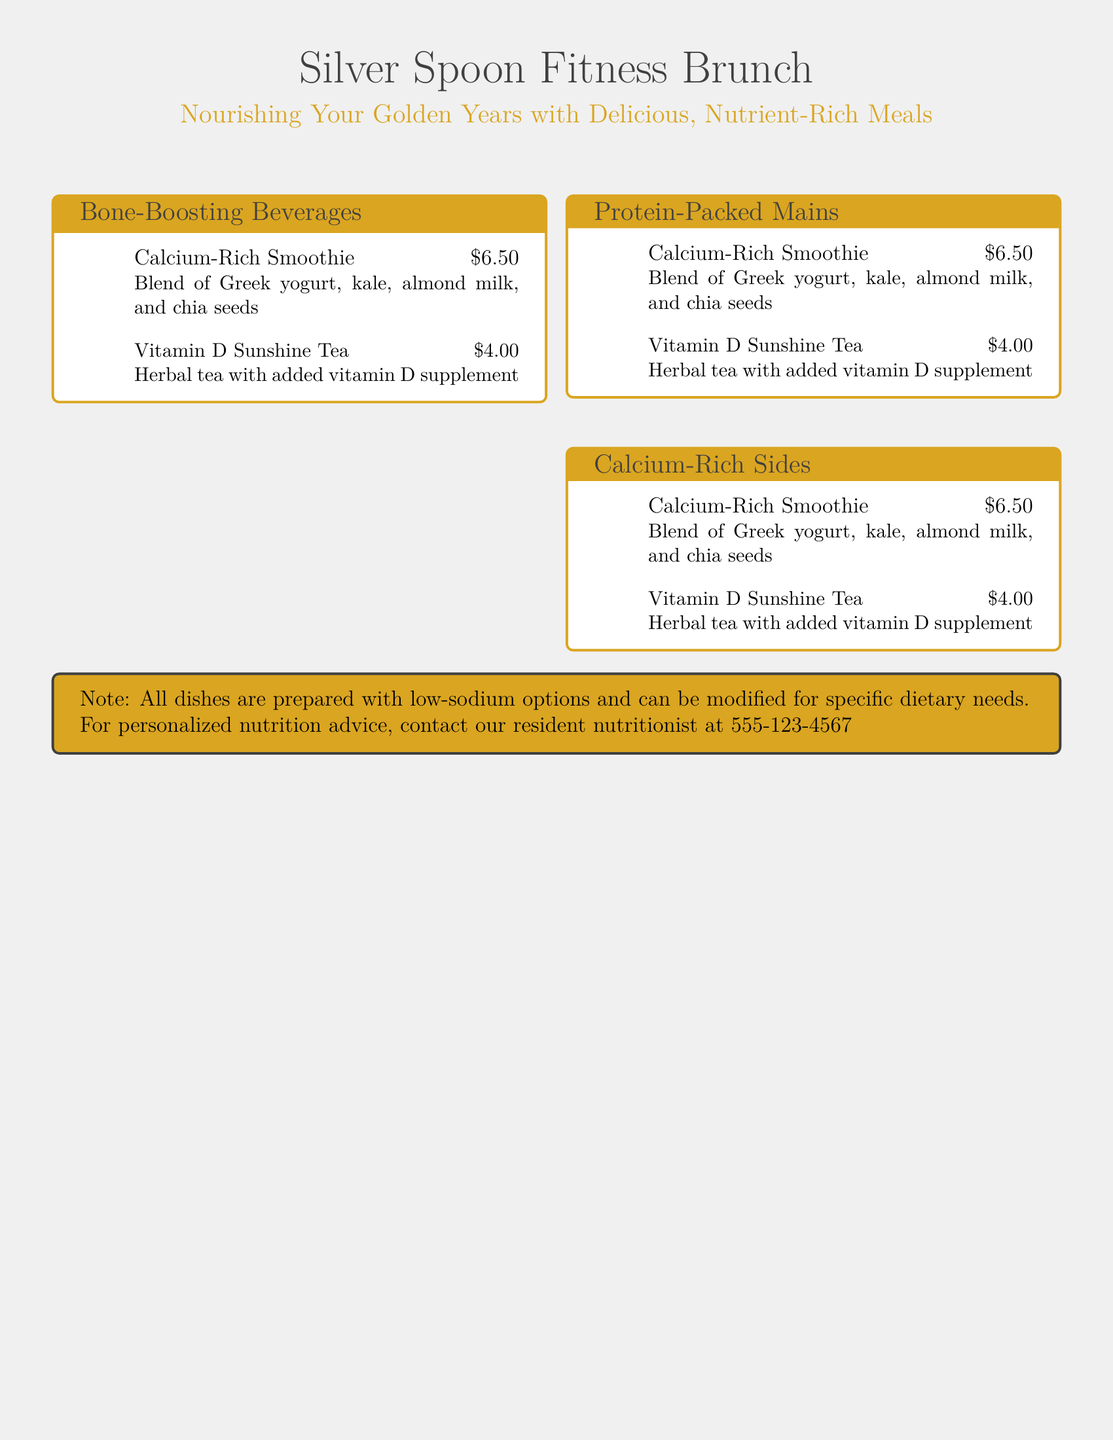What is the name of the menu? The title of the menu is displayed prominently at the top of the document.
Answer: Silver Spoon Fitness Brunch What is the theme of the brunch menu? The theme is indicated in the subtitle, focusing on nutrition for older adults.
Answer: Nourishing Your Golden Years with Delicious, Nutrient-Rich Meals How much does the Calcium-Rich Smoothie cost? The price is listed next to the menu item.
Answer: $6.50 What are the ingredients in the Calcium-Rich Smoothie? The ingredients can be found in the description right below the menu item.
Answer: Greek yogurt, kale, almond milk, and chia seeds What type of tea is featured in the beverages section? The menu lists this item under the beverages category.
Answer: Vitamin D Sunshine Tea Is there a note regarding dietary modifications? The document includes a note section that addresses this.
Answer: Yes What number can be contacted for personalized nutrition advice? The contact number is specified in the note at the bottom of the document.
Answer: 555-123-4567 What color is used for the header text? The color of the title is indicated in the format of the document.
Answer: Dark gray How many sections are there in the menu? The document itemizes the sections, and this can be counted.
Answer: Three 